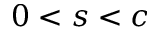Convert formula to latex. <formula><loc_0><loc_0><loc_500><loc_500>0 < s < c</formula> 